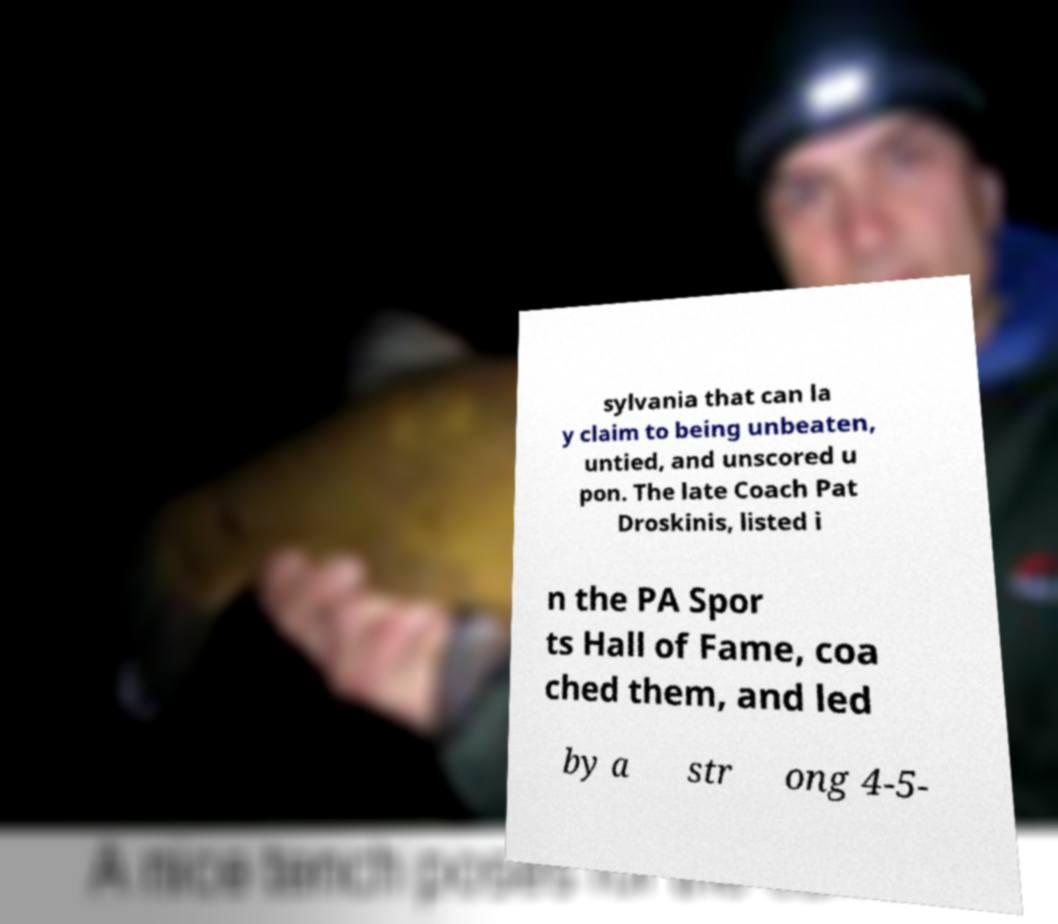Can you accurately transcribe the text from the provided image for me? sylvania that can la y claim to being unbeaten, untied, and unscored u pon. The late Coach Pat Droskinis, listed i n the PA Spor ts Hall of Fame, coa ched them, and led by a str ong 4-5- 